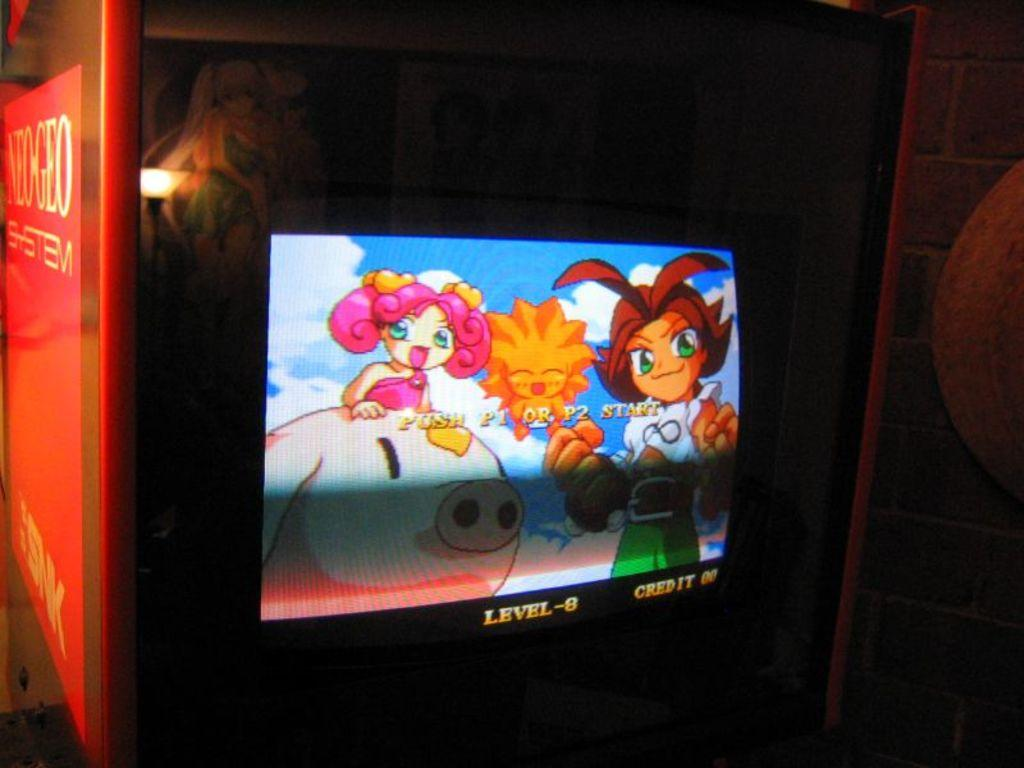<image>
Describe the image concisely. A video game is waiting for player 1 and player 2 to press start. 